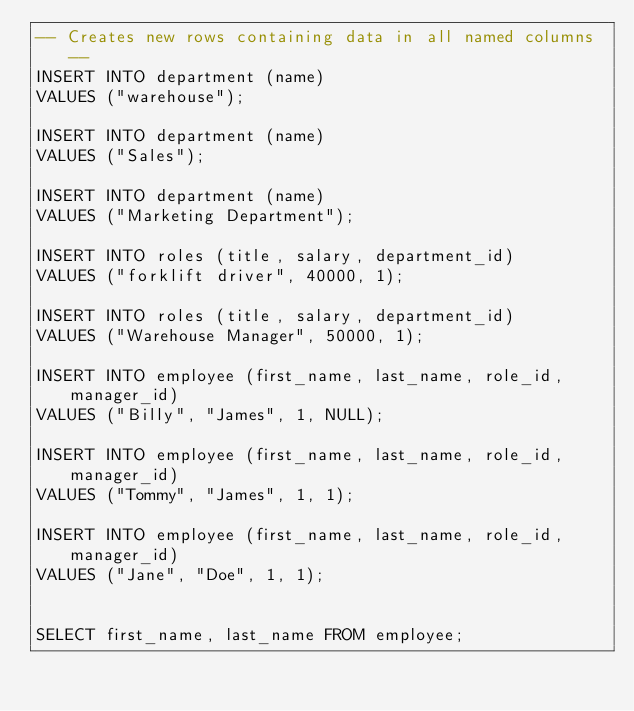Convert code to text. <code><loc_0><loc_0><loc_500><loc_500><_SQL_>-- Creates new rows containing data in all named columns --
INSERT INTO department (name)
VALUES ("warehouse");

INSERT INTO department (name)
VALUES ("Sales");

INSERT INTO department (name)
VALUES ("Marketing Department");

INSERT INTO roles (title, salary, department_id)
VALUES ("forklift driver", 40000, 1);

INSERT INTO roles (title, salary, department_id)
VALUES ("Warehouse Manager", 50000, 1);

INSERT INTO employee (first_name, last_name, role_id, manager_id)
VALUES ("Billy", "James", 1, NULL);

INSERT INTO employee (first_name, last_name, role_id, manager_id)
VALUES ("Tommy", "James", 1, 1);

INSERT INTO employee (first_name, last_name, role_id, manager_id)
VALUES ("Jane", "Doe", 1, 1);


SELECT first_name, last_name FROM employee;
</code> 